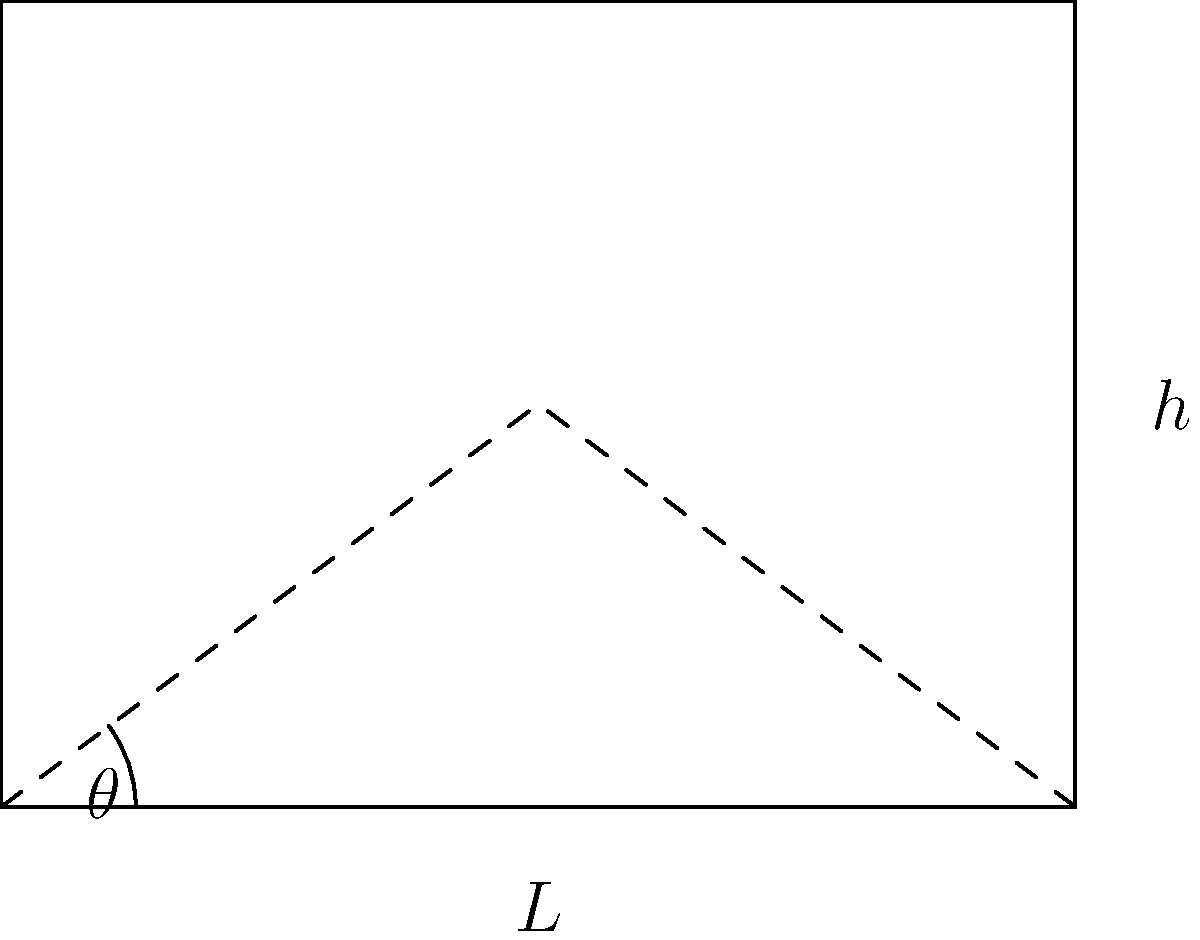A furniture designer is creating a reclining chair for maximum comfort. The chair's backrest can be adjusted to form an angle $\theta$ with the horizontal seat. The designer hypothesizes that the optimal angle $\theta$ is related to the user's height $h$ and the chair's length $L$. The comfort function is given by:

$$C(\theta) = 100\sin(\theta)\cos(\theta) - 5\left(\frac{h}{L} - \tan(\theta)\right)^2$$

where $C$ is the comfort level, $h$ is the user's height, and $L$ is the chair's length. For a user who is 180 cm tall and a chair that is 120 cm long, find the optimal angle $\theta$ (in degrees) that maximizes comfort. To find the optimal angle, we need to follow these steps:

1) First, let's substitute the given values: $h = 180$ cm and $L = 120$ cm.

2) The comfort function becomes:
   $$C(\theta) = 100\sin(\theta)\cos(\theta) - 5\left(\frac{180}{120} - \tan(\theta)\right)^2$$
   $$C(\theta) = 100\sin(\theta)\cos(\theta) - 5(1.5 - \tan(\theta))^2$$

3) To find the maximum, we need to differentiate $C(\theta)$ with respect to $\theta$ and set it to zero:
   $$\frac{dC}{d\theta} = 100(\cos^2(\theta) - \sin^2(\theta)) + 10(1.5 - \tan(\theta))\sec^2(\theta) = 0$$

4) Using the identity $\cos^2(\theta) - \sin^2(\theta) = \cos(2\theta)$, we get:
   $$100\cos(2\theta) + 10(1.5 - \tan(\theta))\sec^2(\theta) = 0$$

5) This equation is complex and doesn't have a straightforward analytical solution. We need to solve it numerically.

6) Using a numerical method (e.g., Newton-Raphson), we find that the equation is satisfied when $\theta \approx 0.9553$ radians.

7) Converting to degrees: $0.9553 \times \frac{180}{\pi} \approx 54.7°$

Therefore, the optimal angle for maximum comfort is approximately 54.7°.
Answer: 54.7° 